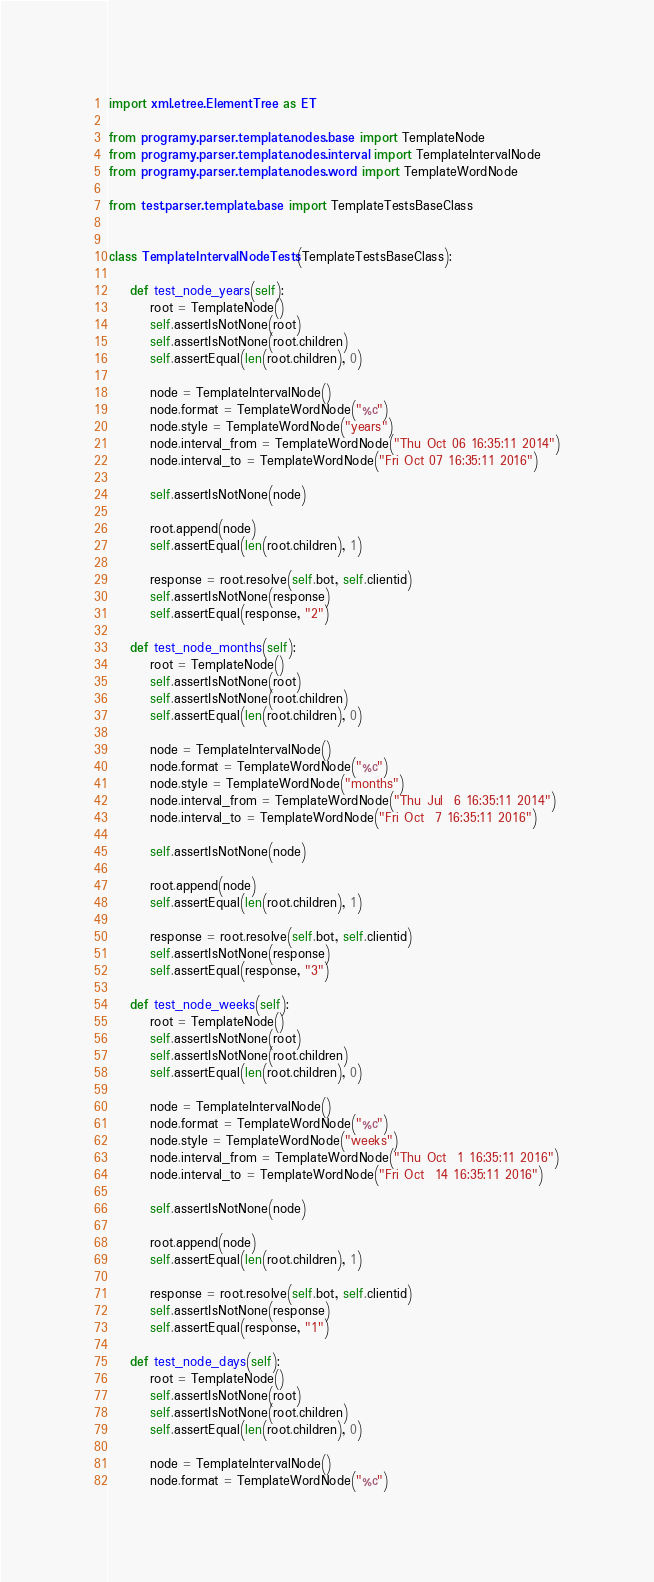<code> <loc_0><loc_0><loc_500><loc_500><_Python_>import xml.etree.ElementTree as ET

from programy.parser.template.nodes.base import TemplateNode
from programy.parser.template.nodes.interval import TemplateIntervalNode
from programy.parser.template.nodes.word import TemplateWordNode

from test.parser.template.base import TemplateTestsBaseClass


class TemplateIntervalNodeTests(TemplateTestsBaseClass):

    def test_node_years(self):
        root = TemplateNode()
        self.assertIsNotNone(root)
        self.assertIsNotNone(root.children)
        self.assertEqual(len(root.children), 0)

        node = TemplateIntervalNode()
        node.format = TemplateWordNode("%c")
        node.style = TemplateWordNode("years")
        node.interval_from = TemplateWordNode("Thu Oct 06 16:35:11 2014")
        node.interval_to = TemplateWordNode("Fri Oct 07 16:35:11 2016")

        self.assertIsNotNone(node)

        root.append(node)
        self.assertEqual(len(root.children), 1)

        response = root.resolve(self.bot, self.clientid)
        self.assertIsNotNone(response)
        self.assertEqual(response, "2")

    def test_node_months(self):
        root = TemplateNode()
        self.assertIsNotNone(root)
        self.assertIsNotNone(root.children)
        self.assertEqual(len(root.children), 0)

        node = TemplateIntervalNode()
        node.format = TemplateWordNode("%c")
        node.style = TemplateWordNode("months")
        node.interval_from = TemplateWordNode("Thu Jul  6 16:35:11 2014")
        node.interval_to = TemplateWordNode("Fri Oct  7 16:35:11 2016")

        self.assertIsNotNone(node)

        root.append(node)
        self.assertEqual(len(root.children), 1)

        response = root.resolve(self.bot, self.clientid)
        self.assertIsNotNone(response)
        self.assertEqual(response, "3")

    def test_node_weeks(self):
        root = TemplateNode()
        self.assertIsNotNone(root)
        self.assertIsNotNone(root.children)
        self.assertEqual(len(root.children), 0)

        node = TemplateIntervalNode()
        node.format = TemplateWordNode("%c")
        node.style = TemplateWordNode("weeks")
        node.interval_from = TemplateWordNode("Thu Oct  1 16:35:11 2016")
        node.interval_to = TemplateWordNode("Fri Oct  14 16:35:11 2016")

        self.assertIsNotNone(node)

        root.append(node)
        self.assertEqual(len(root.children), 1)

        response = root.resolve(self.bot, self.clientid)
        self.assertIsNotNone(response)
        self.assertEqual(response, "1")

    def test_node_days(self):
        root = TemplateNode()
        self.assertIsNotNone(root)
        self.assertIsNotNone(root.children)
        self.assertEqual(len(root.children), 0)

        node = TemplateIntervalNode()
        node.format = TemplateWordNode("%c")</code> 